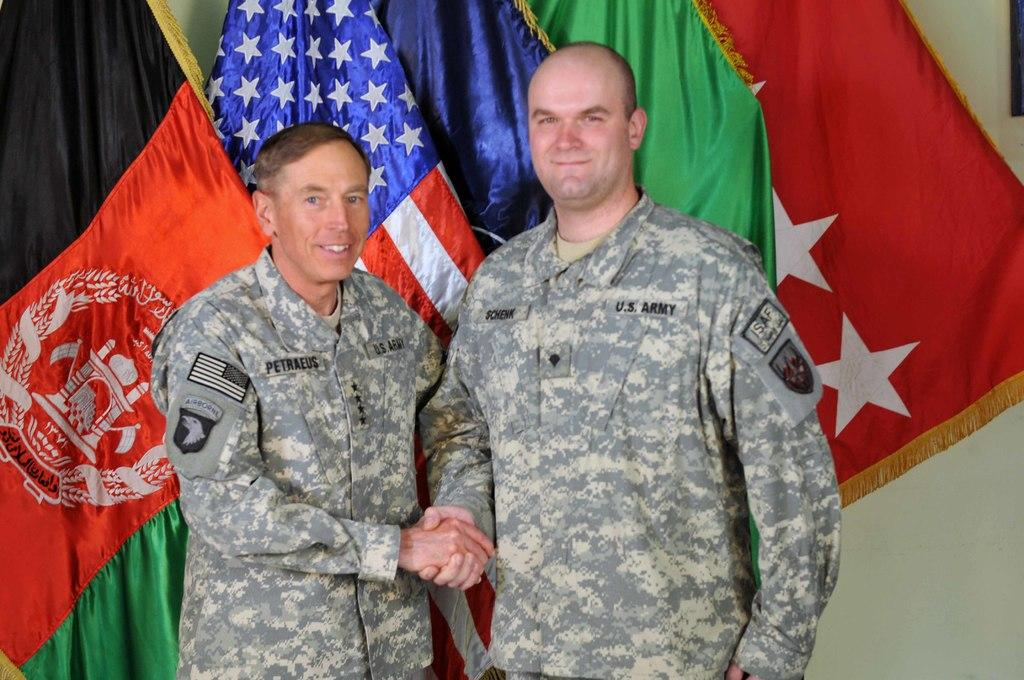How many people are in the image? There are two persons in the image. What are the persons doing in the image? The persons are standing with a smile and shaking hands. What can be seen in the background of the image? There are flags visible in the image, and there is a wall in the image. What degree of steel is being used to construct the wall in the image? There is no mention of steel or construction in the image; it only shows two persons shaking hands with flags in the background. 